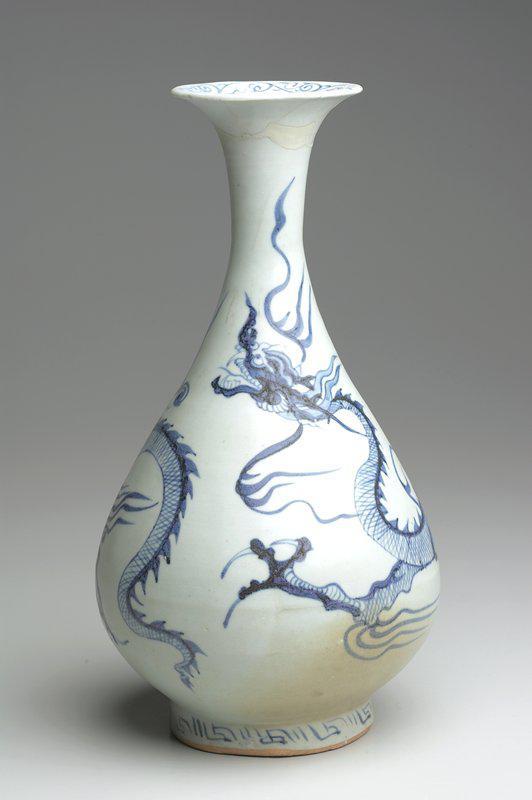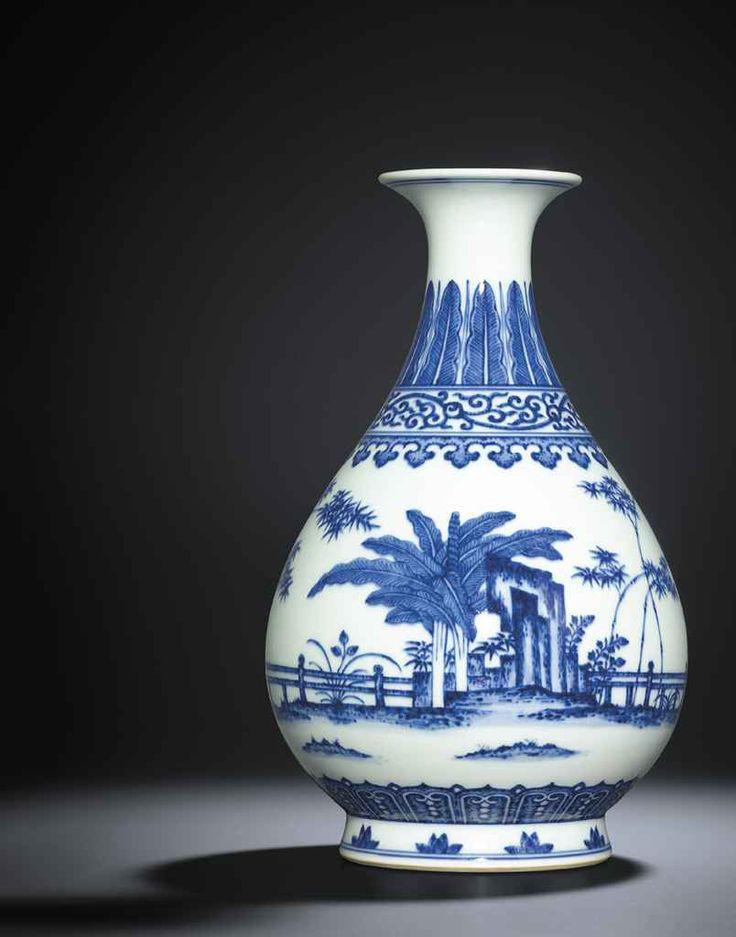The first image is the image on the left, the second image is the image on the right. Examine the images to the left and right. Is the description "One of the images shows a plain white vase." accurate? Answer yes or no. No. The first image is the image on the left, the second image is the image on the right. For the images displayed, is the sentence "Each vase has a round pair shaped base with a skinny neck and a fluted opening at the top." factually correct? Answer yes or no. Yes. 